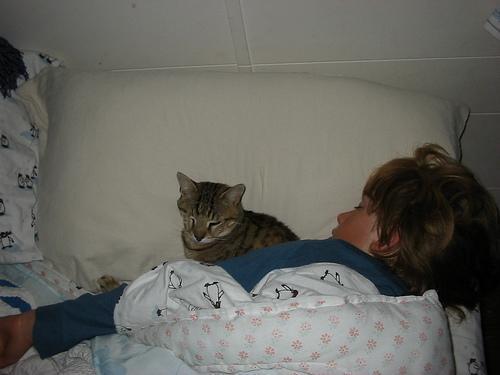How many tracks have a train on them?
Give a very brief answer. 0. 